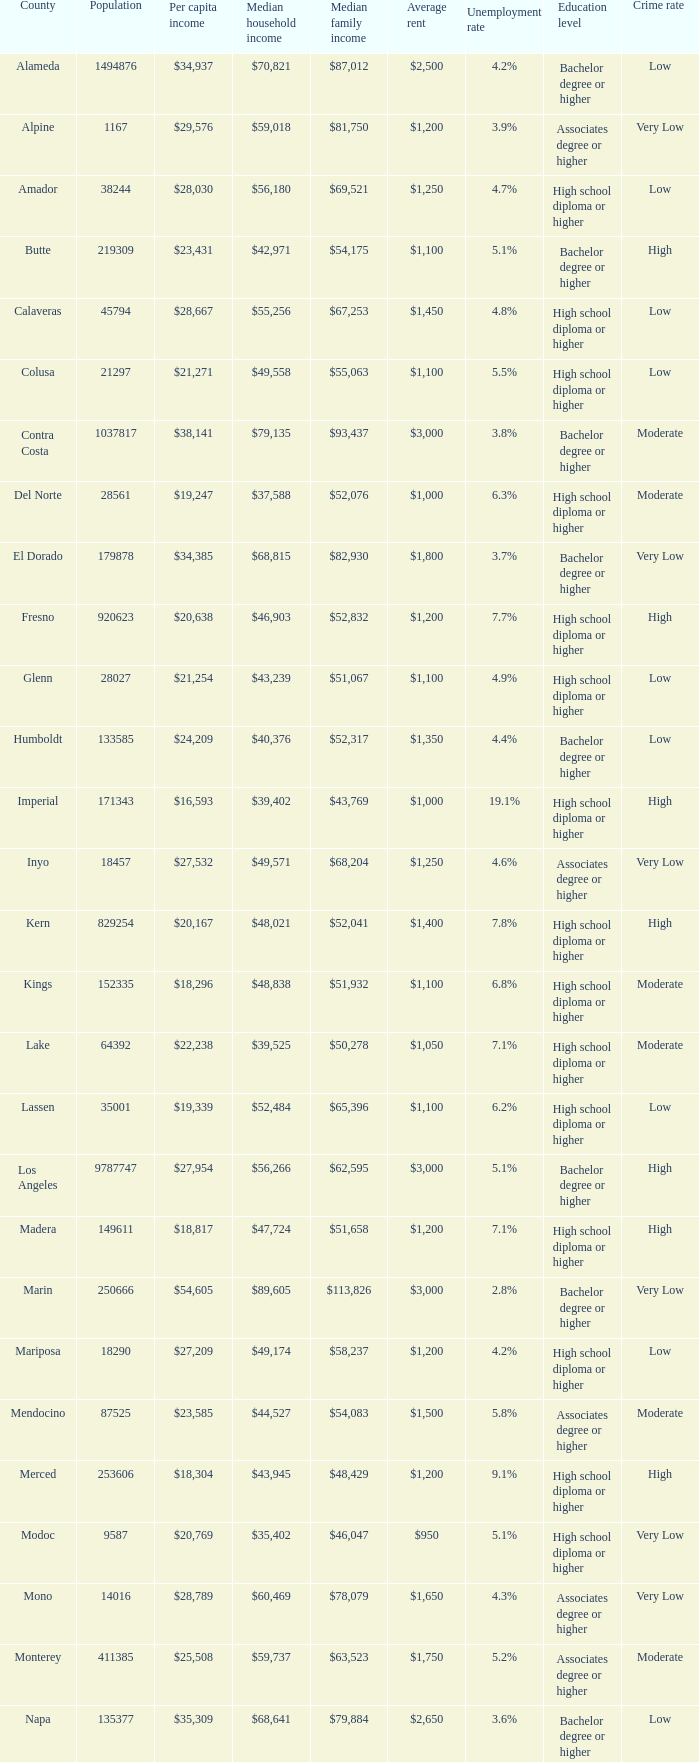What is the average household income for riverside? $65,457. 